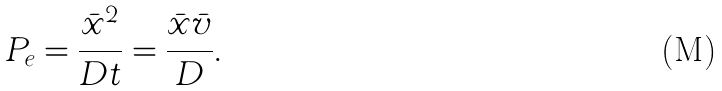<formula> <loc_0><loc_0><loc_500><loc_500>P _ { e } = \frac { { \bar { x } } ^ { 2 } } { D t } = \frac { { \bar { x } } { \bar { v } } } { D } .</formula> 